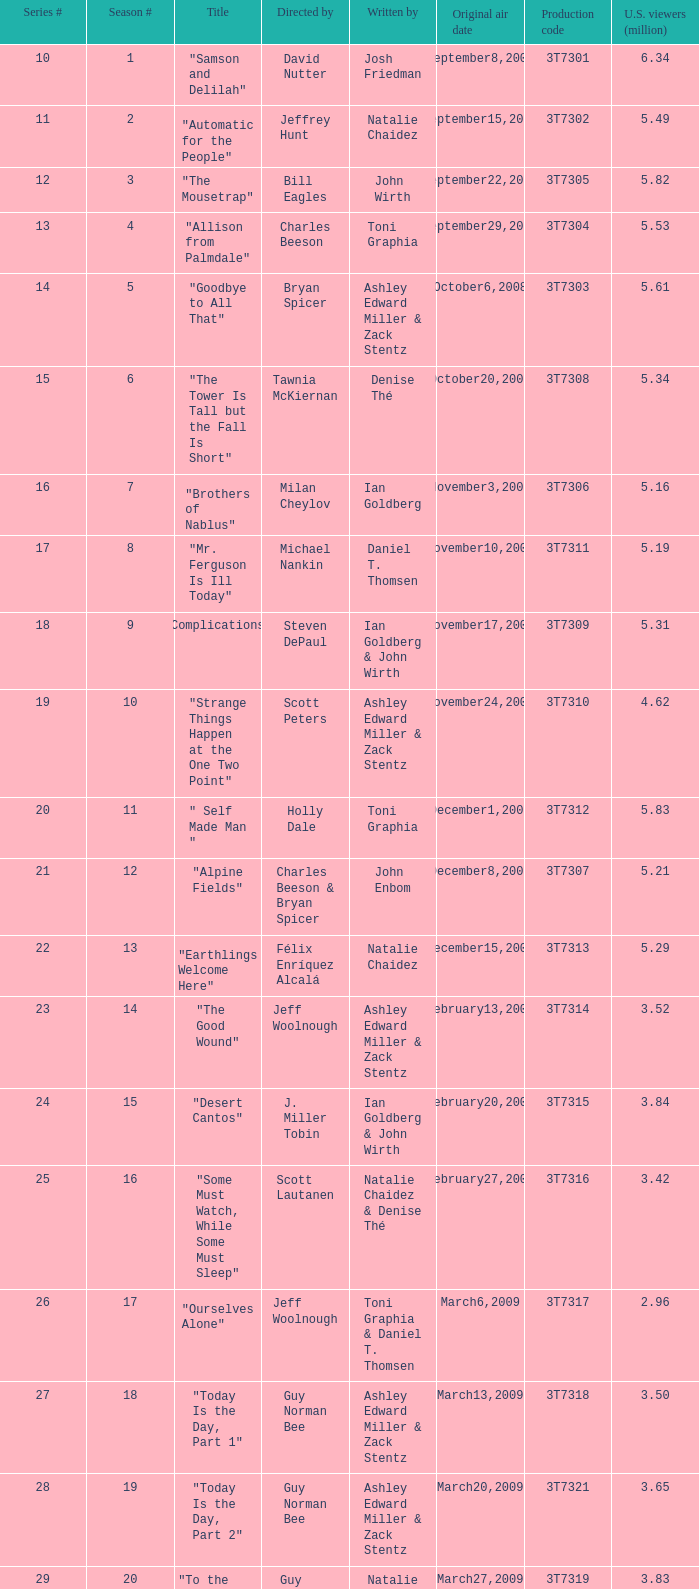How many viewers did the episode directed by David Nutter draw in? 6.34. 